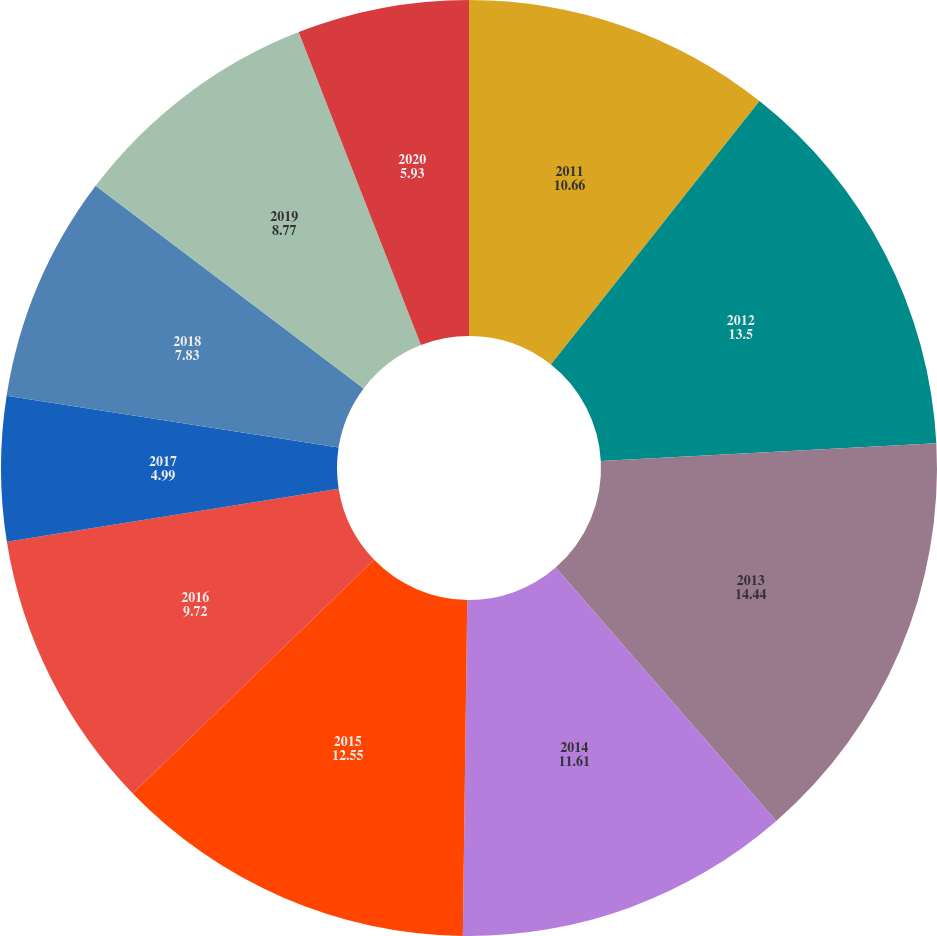Convert chart to OTSL. <chart><loc_0><loc_0><loc_500><loc_500><pie_chart><fcel>2011<fcel>2012<fcel>2013<fcel>2014<fcel>2015<fcel>2016<fcel>2017<fcel>2018<fcel>2019<fcel>2020<nl><fcel>10.66%<fcel>13.5%<fcel>14.44%<fcel>11.61%<fcel>12.55%<fcel>9.72%<fcel>4.99%<fcel>7.83%<fcel>8.77%<fcel>5.93%<nl></chart> 